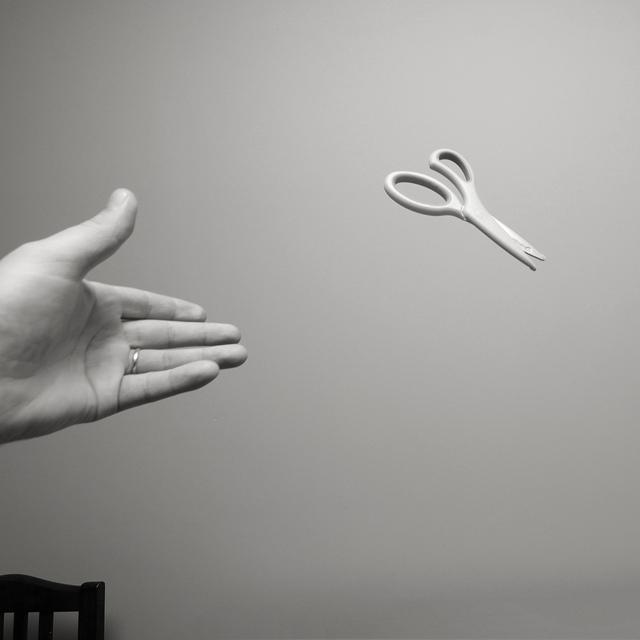How will the scissors move next?
Answer the question by selecting the correct answer among the 4 following choices.
Options: Straight up, remain still, arc downwards, straight down. Arc downwards. 